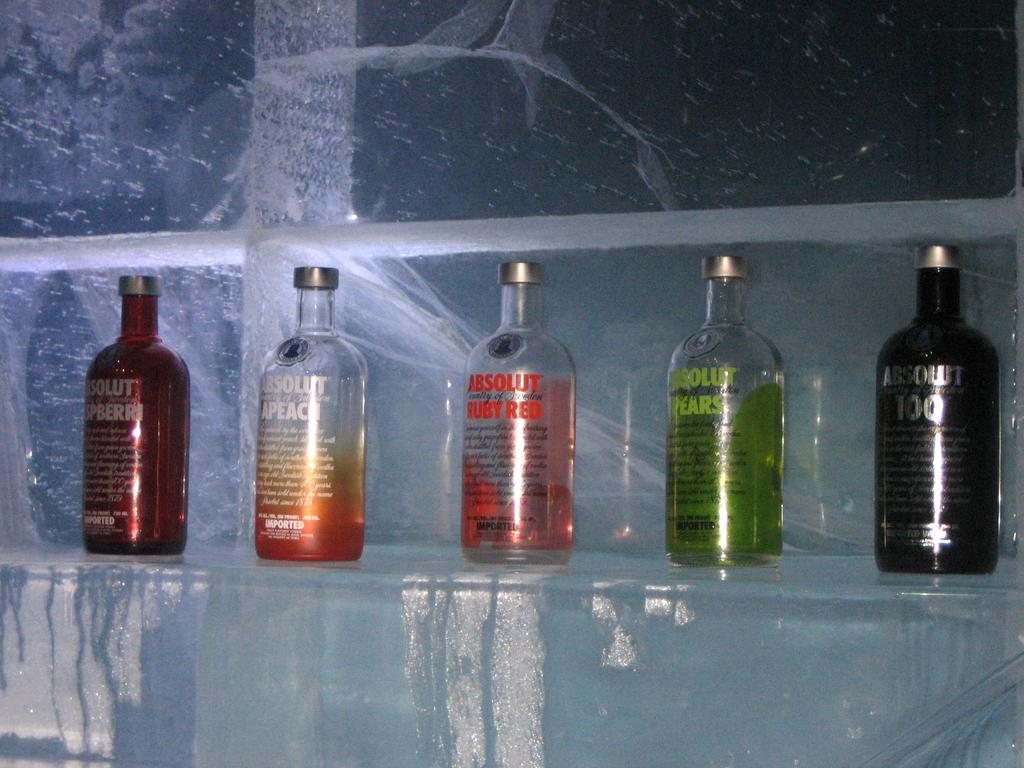<image>
Give a short and clear explanation of the subsequent image. Five different bottles of Absolut next to each other. 